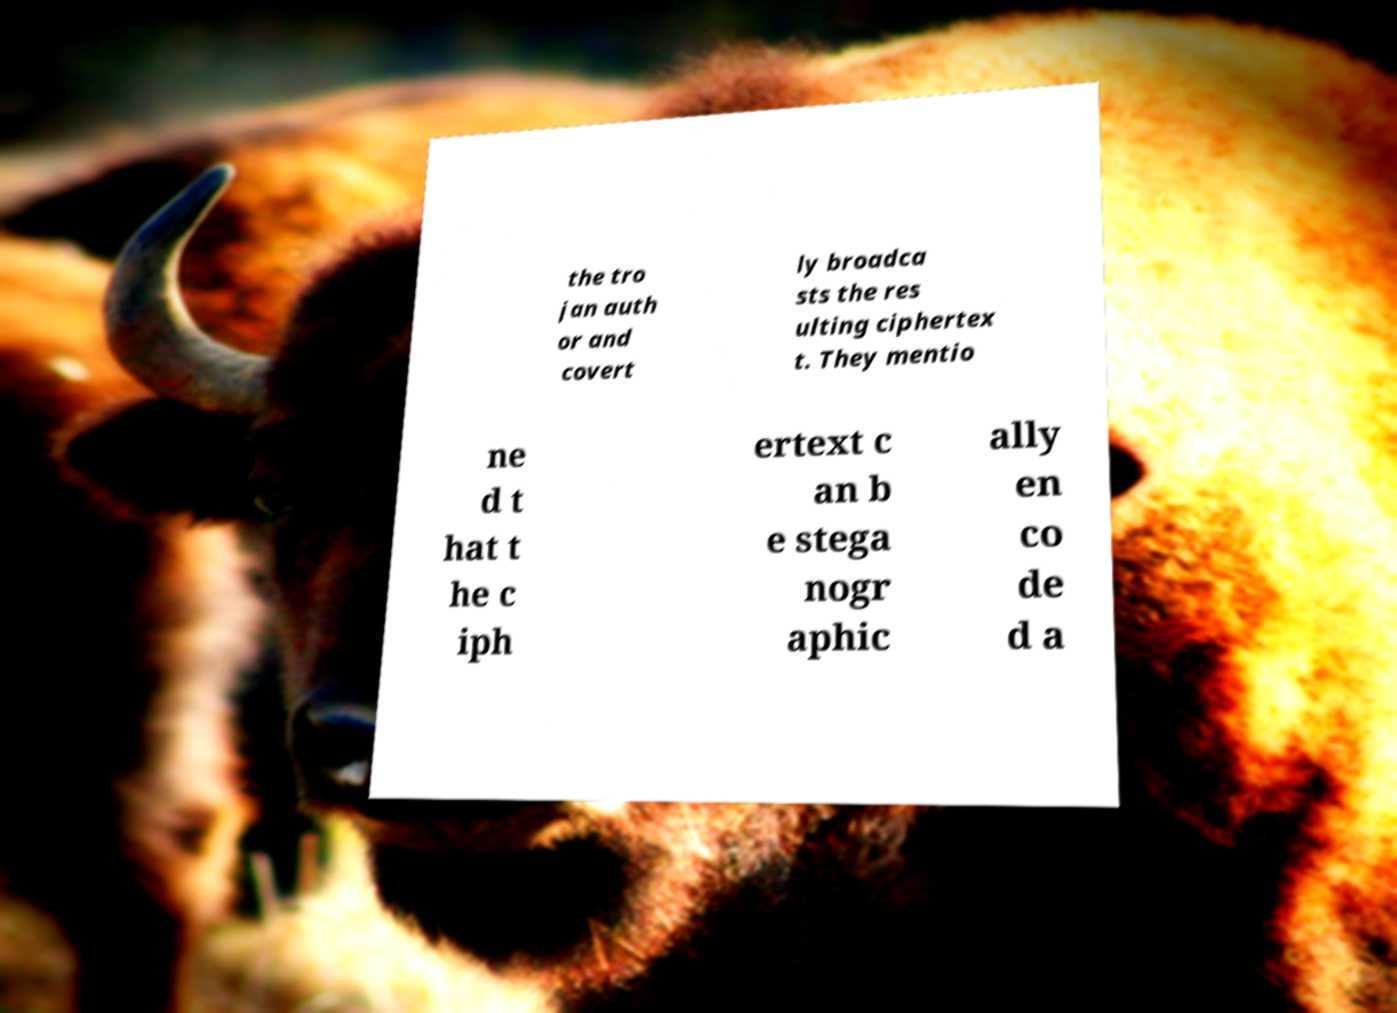For documentation purposes, I need the text within this image transcribed. Could you provide that? the tro jan auth or and covert ly broadca sts the res ulting ciphertex t. They mentio ne d t hat t he c iph ertext c an b e stega nogr aphic ally en co de d a 